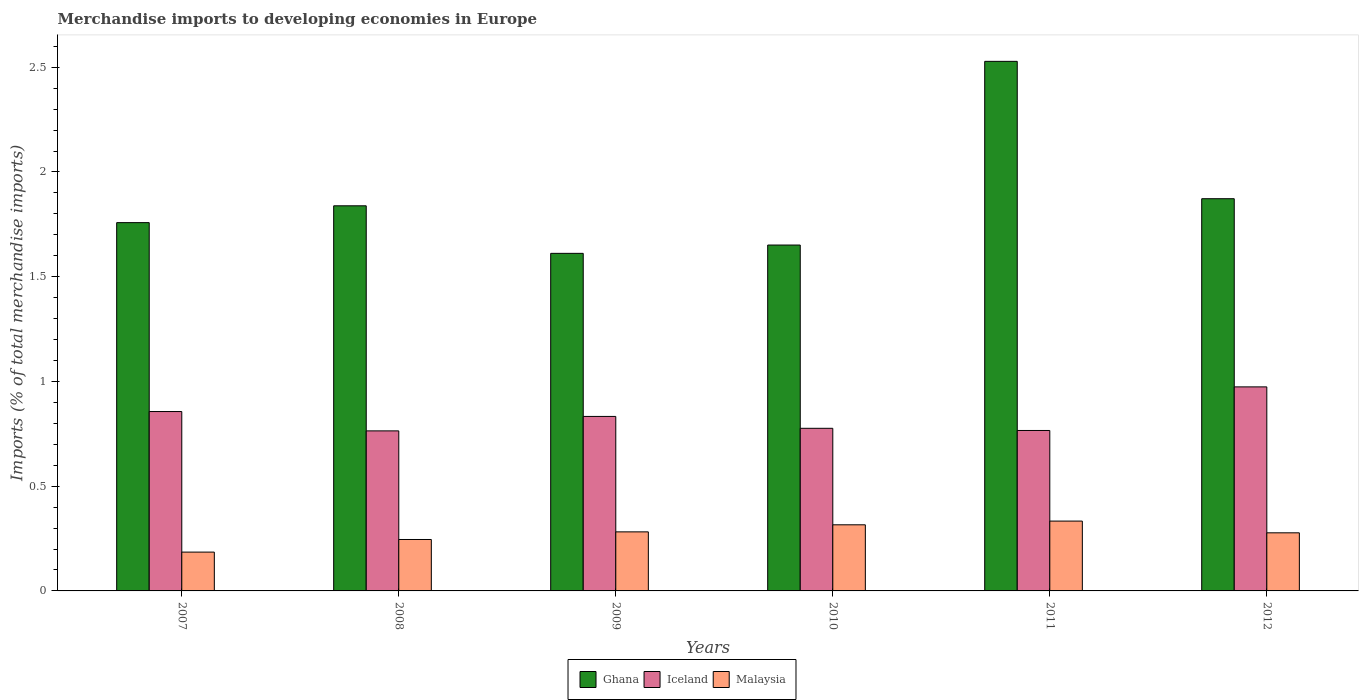How many groups of bars are there?
Offer a very short reply. 6. Are the number of bars per tick equal to the number of legend labels?
Ensure brevity in your answer.  Yes. Are the number of bars on each tick of the X-axis equal?
Keep it short and to the point. Yes. How many bars are there on the 6th tick from the left?
Keep it short and to the point. 3. How many bars are there on the 2nd tick from the right?
Offer a very short reply. 3. What is the label of the 1st group of bars from the left?
Offer a terse response. 2007. In how many cases, is the number of bars for a given year not equal to the number of legend labels?
Provide a succinct answer. 0. What is the percentage total merchandise imports in Malaysia in 2007?
Keep it short and to the point. 0.19. Across all years, what is the maximum percentage total merchandise imports in Ghana?
Your response must be concise. 2.53. Across all years, what is the minimum percentage total merchandise imports in Ghana?
Make the answer very short. 1.61. In which year was the percentage total merchandise imports in Malaysia maximum?
Your answer should be very brief. 2011. What is the total percentage total merchandise imports in Ghana in the graph?
Your response must be concise. 11.26. What is the difference between the percentage total merchandise imports in Iceland in 2008 and that in 2009?
Offer a terse response. -0.07. What is the difference between the percentage total merchandise imports in Iceland in 2011 and the percentage total merchandise imports in Malaysia in 2007?
Make the answer very short. 0.58. What is the average percentage total merchandise imports in Ghana per year?
Offer a very short reply. 1.88. In the year 2010, what is the difference between the percentage total merchandise imports in Malaysia and percentage total merchandise imports in Ghana?
Provide a succinct answer. -1.34. In how many years, is the percentage total merchandise imports in Malaysia greater than 1.6 %?
Make the answer very short. 0. What is the ratio of the percentage total merchandise imports in Ghana in 2007 to that in 2009?
Give a very brief answer. 1.09. What is the difference between the highest and the second highest percentage total merchandise imports in Iceland?
Give a very brief answer. 0.12. What is the difference between the highest and the lowest percentage total merchandise imports in Malaysia?
Provide a short and direct response. 0.15. What does the 1st bar from the left in 2012 represents?
Offer a terse response. Ghana. What does the 3rd bar from the right in 2012 represents?
Provide a succinct answer. Ghana. How many bars are there?
Offer a terse response. 18. Are the values on the major ticks of Y-axis written in scientific E-notation?
Provide a short and direct response. No. Does the graph contain grids?
Keep it short and to the point. No. Where does the legend appear in the graph?
Ensure brevity in your answer.  Bottom center. How are the legend labels stacked?
Make the answer very short. Horizontal. What is the title of the graph?
Offer a very short reply. Merchandise imports to developing economies in Europe. Does "Nicaragua" appear as one of the legend labels in the graph?
Ensure brevity in your answer.  No. What is the label or title of the Y-axis?
Provide a succinct answer. Imports (% of total merchandise imports). What is the Imports (% of total merchandise imports) in Ghana in 2007?
Keep it short and to the point. 1.76. What is the Imports (% of total merchandise imports) in Iceland in 2007?
Provide a succinct answer. 0.86. What is the Imports (% of total merchandise imports) in Malaysia in 2007?
Your answer should be compact. 0.19. What is the Imports (% of total merchandise imports) in Ghana in 2008?
Keep it short and to the point. 1.84. What is the Imports (% of total merchandise imports) of Iceland in 2008?
Provide a short and direct response. 0.76. What is the Imports (% of total merchandise imports) in Malaysia in 2008?
Your response must be concise. 0.25. What is the Imports (% of total merchandise imports) of Ghana in 2009?
Keep it short and to the point. 1.61. What is the Imports (% of total merchandise imports) in Iceland in 2009?
Your answer should be compact. 0.83. What is the Imports (% of total merchandise imports) in Malaysia in 2009?
Ensure brevity in your answer.  0.28. What is the Imports (% of total merchandise imports) of Ghana in 2010?
Provide a succinct answer. 1.65. What is the Imports (% of total merchandise imports) of Iceland in 2010?
Provide a succinct answer. 0.78. What is the Imports (% of total merchandise imports) of Malaysia in 2010?
Make the answer very short. 0.32. What is the Imports (% of total merchandise imports) of Ghana in 2011?
Keep it short and to the point. 2.53. What is the Imports (% of total merchandise imports) of Iceland in 2011?
Offer a very short reply. 0.77. What is the Imports (% of total merchandise imports) in Malaysia in 2011?
Your response must be concise. 0.33. What is the Imports (% of total merchandise imports) in Ghana in 2012?
Offer a very short reply. 1.87. What is the Imports (% of total merchandise imports) in Iceland in 2012?
Offer a terse response. 0.97. What is the Imports (% of total merchandise imports) of Malaysia in 2012?
Provide a short and direct response. 0.28. Across all years, what is the maximum Imports (% of total merchandise imports) of Ghana?
Offer a very short reply. 2.53. Across all years, what is the maximum Imports (% of total merchandise imports) in Iceland?
Make the answer very short. 0.97. Across all years, what is the maximum Imports (% of total merchandise imports) of Malaysia?
Make the answer very short. 0.33. Across all years, what is the minimum Imports (% of total merchandise imports) of Ghana?
Give a very brief answer. 1.61. Across all years, what is the minimum Imports (% of total merchandise imports) of Iceland?
Offer a terse response. 0.76. Across all years, what is the minimum Imports (% of total merchandise imports) in Malaysia?
Make the answer very short. 0.19. What is the total Imports (% of total merchandise imports) in Ghana in the graph?
Ensure brevity in your answer.  11.26. What is the total Imports (% of total merchandise imports) of Iceland in the graph?
Your response must be concise. 4.97. What is the total Imports (% of total merchandise imports) in Malaysia in the graph?
Offer a very short reply. 1.64. What is the difference between the Imports (% of total merchandise imports) in Ghana in 2007 and that in 2008?
Provide a short and direct response. -0.08. What is the difference between the Imports (% of total merchandise imports) of Iceland in 2007 and that in 2008?
Offer a terse response. 0.09. What is the difference between the Imports (% of total merchandise imports) in Malaysia in 2007 and that in 2008?
Keep it short and to the point. -0.06. What is the difference between the Imports (% of total merchandise imports) of Ghana in 2007 and that in 2009?
Make the answer very short. 0.15. What is the difference between the Imports (% of total merchandise imports) of Iceland in 2007 and that in 2009?
Your answer should be very brief. 0.02. What is the difference between the Imports (% of total merchandise imports) of Malaysia in 2007 and that in 2009?
Your answer should be compact. -0.1. What is the difference between the Imports (% of total merchandise imports) in Ghana in 2007 and that in 2010?
Provide a short and direct response. 0.11. What is the difference between the Imports (% of total merchandise imports) of Iceland in 2007 and that in 2010?
Offer a very short reply. 0.08. What is the difference between the Imports (% of total merchandise imports) in Malaysia in 2007 and that in 2010?
Offer a terse response. -0.13. What is the difference between the Imports (% of total merchandise imports) in Ghana in 2007 and that in 2011?
Provide a succinct answer. -0.77. What is the difference between the Imports (% of total merchandise imports) of Iceland in 2007 and that in 2011?
Offer a very short reply. 0.09. What is the difference between the Imports (% of total merchandise imports) in Malaysia in 2007 and that in 2011?
Offer a terse response. -0.15. What is the difference between the Imports (% of total merchandise imports) of Ghana in 2007 and that in 2012?
Give a very brief answer. -0.11. What is the difference between the Imports (% of total merchandise imports) in Iceland in 2007 and that in 2012?
Offer a terse response. -0.12. What is the difference between the Imports (% of total merchandise imports) in Malaysia in 2007 and that in 2012?
Keep it short and to the point. -0.09. What is the difference between the Imports (% of total merchandise imports) of Ghana in 2008 and that in 2009?
Make the answer very short. 0.23. What is the difference between the Imports (% of total merchandise imports) in Iceland in 2008 and that in 2009?
Give a very brief answer. -0.07. What is the difference between the Imports (% of total merchandise imports) in Malaysia in 2008 and that in 2009?
Offer a terse response. -0.04. What is the difference between the Imports (% of total merchandise imports) in Ghana in 2008 and that in 2010?
Ensure brevity in your answer.  0.19. What is the difference between the Imports (% of total merchandise imports) of Iceland in 2008 and that in 2010?
Your answer should be very brief. -0.01. What is the difference between the Imports (% of total merchandise imports) in Malaysia in 2008 and that in 2010?
Offer a very short reply. -0.07. What is the difference between the Imports (% of total merchandise imports) of Ghana in 2008 and that in 2011?
Keep it short and to the point. -0.69. What is the difference between the Imports (% of total merchandise imports) in Iceland in 2008 and that in 2011?
Offer a very short reply. -0. What is the difference between the Imports (% of total merchandise imports) in Malaysia in 2008 and that in 2011?
Offer a terse response. -0.09. What is the difference between the Imports (% of total merchandise imports) in Ghana in 2008 and that in 2012?
Give a very brief answer. -0.03. What is the difference between the Imports (% of total merchandise imports) in Iceland in 2008 and that in 2012?
Ensure brevity in your answer.  -0.21. What is the difference between the Imports (% of total merchandise imports) of Malaysia in 2008 and that in 2012?
Keep it short and to the point. -0.03. What is the difference between the Imports (% of total merchandise imports) of Ghana in 2009 and that in 2010?
Offer a very short reply. -0.04. What is the difference between the Imports (% of total merchandise imports) in Iceland in 2009 and that in 2010?
Provide a succinct answer. 0.06. What is the difference between the Imports (% of total merchandise imports) of Malaysia in 2009 and that in 2010?
Make the answer very short. -0.03. What is the difference between the Imports (% of total merchandise imports) in Ghana in 2009 and that in 2011?
Provide a succinct answer. -0.92. What is the difference between the Imports (% of total merchandise imports) in Iceland in 2009 and that in 2011?
Provide a short and direct response. 0.07. What is the difference between the Imports (% of total merchandise imports) of Malaysia in 2009 and that in 2011?
Give a very brief answer. -0.05. What is the difference between the Imports (% of total merchandise imports) of Ghana in 2009 and that in 2012?
Keep it short and to the point. -0.26. What is the difference between the Imports (% of total merchandise imports) in Iceland in 2009 and that in 2012?
Provide a succinct answer. -0.14. What is the difference between the Imports (% of total merchandise imports) of Malaysia in 2009 and that in 2012?
Ensure brevity in your answer.  0. What is the difference between the Imports (% of total merchandise imports) in Ghana in 2010 and that in 2011?
Your answer should be compact. -0.88. What is the difference between the Imports (% of total merchandise imports) of Iceland in 2010 and that in 2011?
Give a very brief answer. 0.01. What is the difference between the Imports (% of total merchandise imports) in Malaysia in 2010 and that in 2011?
Offer a very short reply. -0.02. What is the difference between the Imports (% of total merchandise imports) of Ghana in 2010 and that in 2012?
Give a very brief answer. -0.22. What is the difference between the Imports (% of total merchandise imports) in Iceland in 2010 and that in 2012?
Your response must be concise. -0.2. What is the difference between the Imports (% of total merchandise imports) of Malaysia in 2010 and that in 2012?
Keep it short and to the point. 0.04. What is the difference between the Imports (% of total merchandise imports) in Ghana in 2011 and that in 2012?
Provide a succinct answer. 0.66. What is the difference between the Imports (% of total merchandise imports) in Iceland in 2011 and that in 2012?
Your answer should be compact. -0.21. What is the difference between the Imports (% of total merchandise imports) of Malaysia in 2011 and that in 2012?
Provide a succinct answer. 0.06. What is the difference between the Imports (% of total merchandise imports) of Ghana in 2007 and the Imports (% of total merchandise imports) of Iceland in 2008?
Your response must be concise. 0.99. What is the difference between the Imports (% of total merchandise imports) in Ghana in 2007 and the Imports (% of total merchandise imports) in Malaysia in 2008?
Give a very brief answer. 1.51. What is the difference between the Imports (% of total merchandise imports) in Iceland in 2007 and the Imports (% of total merchandise imports) in Malaysia in 2008?
Keep it short and to the point. 0.61. What is the difference between the Imports (% of total merchandise imports) in Ghana in 2007 and the Imports (% of total merchandise imports) in Iceland in 2009?
Your answer should be very brief. 0.93. What is the difference between the Imports (% of total merchandise imports) in Ghana in 2007 and the Imports (% of total merchandise imports) in Malaysia in 2009?
Give a very brief answer. 1.48. What is the difference between the Imports (% of total merchandise imports) of Iceland in 2007 and the Imports (% of total merchandise imports) of Malaysia in 2009?
Offer a terse response. 0.57. What is the difference between the Imports (% of total merchandise imports) in Ghana in 2007 and the Imports (% of total merchandise imports) in Iceland in 2010?
Offer a very short reply. 0.98. What is the difference between the Imports (% of total merchandise imports) in Ghana in 2007 and the Imports (% of total merchandise imports) in Malaysia in 2010?
Give a very brief answer. 1.44. What is the difference between the Imports (% of total merchandise imports) of Iceland in 2007 and the Imports (% of total merchandise imports) of Malaysia in 2010?
Your answer should be very brief. 0.54. What is the difference between the Imports (% of total merchandise imports) in Ghana in 2007 and the Imports (% of total merchandise imports) in Malaysia in 2011?
Your answer should be compact. 1.42. What is the difference between the Imports (% of total merchandise imports) of Iceland in 2007 and the Imports (% of total merchandise imports) of Malaysia in 2011?
Your answer should be very brief. 0.52. What is the difference between the Imports (% of total merchandise imports) of Ghana in 2007 and the Imports (% of total merchandise imports) of Iceland in 2012?
Provide a succinct answer. 0.78. What is the difference between the Imports (% of total merchandise imports) of Ghana in 2007 and the Imports (% of total merchandise imports) of Malaysia in 2012?
Give a very brief answer. 1.48. What is the difference between the Imports (% of total merchandise imports) of Iceland in 2007 and the Imports (% of total merchandise imports) of Malaysia in 2012?
Provide a short and direct response. 0.58. What is the difference between the Imports (% of total merchandise imports) in Ghana in 2008 and the Imports (% of total merchandise imports) in Malaysia in 2009?
Your answer should be compact. 1.56. What is the difference between the Imports (% of total merchandise imports) of Iceland in 2008 and the Imports (% of total merchandise imports) of Malaysia in 2009?
Give a very brief answer. 0.48. What is the difference between the Imports (% of total merchandise imports) in Ghana in 2008 and the Imports (% of total merchandise imports) in Iceland in 2010?
Keep it short and to the point. 1.06. What is the difference between the Imports (% of total merchandise imports) of Ghana in 2008 and the Imports (% of total merchandise imports) of Malaysia in 2010?
Provide a succinct answer. 1.52. What is the difference between the Imports (% of total merchandise imports) of Iceland in 2008 and the Imports (% of total merchandise imports) of Malaysia in 2010?
Provide a succinct answer. 0.45. What is the difference between the Imports (% of total merchandise imports) of Ghana in 2008 and the Imports (% of total merchandise imports) of Iceland in 2011?
Make the answer very short. 1.07. What is the difference between the Imports (% of total merchandise imports) of Ghana in 2008 and the Imports (% of total merchandise imports) of Malaysia in 2011?
Offer a terse response. 1.5. What is the difference between the Imports (% of total merchandise imports) of Iceland in 2008 and the Imports (% of total merchandise imports) of Malaysia in 2011?
Ensure brevity in your answer.  0.43. What is the difference between the Imports (% of total merchandise imports) in Ghana in 2008 and the Imports (% of total merchandise imports) in Iceland in 2012?
Offer a terse response. 0.86. What is the difference between the Imports (% of total merchandise imports) of Ghana in 2008 and the Imports (% of total merchandise imports) of Malaysia in 2012?
Keep it short and to the point. 1.56. What is the difference between the Imports (% of total merchandise imports) of Iceland in 2008 and the Imports (% of total merchandise imports) of Malaysia in 2012?
Offer a terse response. 0.49. What is the difference between the Imports (% of total merchandise imports) of Ghana in 2009 and the Imports (% of total merchandise imports) of Iceland in 2010?
Ensure brevity in your answer.  0.84. What is the difference between the Imports (% of total merchandise imports) in Ghana in 2009 and the Imports (% of total merchandise imports) in Malaysia in 2010?
Offer a very short reply. 1.3. What is the difference between the Imports (% of total merchandise imports) in Iceland in 2009 and the Imports (% of total merchandise imports) in Malaysia in 2010?
Keep it short and to the point. 0.52. What is the difference between the Imports (% of total merchandise imports) of Ghana in 2009 and the Imports (% of total merchandise imports) of Iceland in 2011?
Make the answer very short. 0.85. What is the difference between the Imports (% of total merchandise imports) of Ghana in 2009 and the Imports (% of total merchandise imports) of Malaysia in 2011?
Your answer should be compact. 1.28. What is the difference between the Imports (% of total merchandise imports) of Iceland in 2009 and the Imports (% of total merchandise imports) of Malaysia in 2011?
Ensure brevity in your answer.  0.5. What is the difference between the Imports (% of total merchandise imports) of Ghana in 2009 and the Imports (% of total merchandise imports) of Iceland in 2012?
Your answer should be very brief. 0.64. What is the difference between the Imports (% of total merchandise imports) of Ghana in 2009 and the Imports (% of total merchandise imports) of Malaysia in 2012?
Make the answer very short. 1.33. What is the difference between the Imports (% of total merchandise imports) of Iceland in 2009 and the Imports (% of total merchandise imports) of Malaysia in 2012?
Provide a short and direct response. 0.56. What is the difference between the Imports (% of total merchandise imports) in Ghana in 2010 and the Imports (% of total merchandise imports) in Iceland in 2011?
Ensure brevity in your answer.  0.89. What is the difference between the Imports (% of total merchandise imports) of Ghana in 2010 and the Imports (% of total merchandise imports) of Malaysia in 2011?
Ensure brevity in your answer.  1.32. What is the difference between the Imports (% of total merchandise imports) of Iceland in 2010 and the Imports (% of total merchandise imports) of Malaysia in 2011?
Ensure brevity in your answer.  0.44. What is the difference between the Imports (% of total merchandise imports) of Ghana in 2010 and the Imports (% of total merchandise imports) of Iceland in 2012?
Provide a short and direct response. 0.68. What is the difference between the Imports (% of total merchandise imports) of Ghana in 2010 and the Imports (% of total merchandise imports) of Malaysia in 2012?
Provide a succinct answer. 1.37. What is the difference between the Imports (% of total merchandise imports) in Iceland in 2010 and the Imports (% of total merchandise imports) in Malaysia in 2012?
Your response must be concise. 0.5. What is the difference between the Imports (% of total merchandise imports) in Ghana in 2011 and the Imports (% of total merchandise imports) in Iceland in 2012?
Offer a terse response. 1.55. What is the difference between the Imports (% of total merchandise imports) of Ghana in 2011 and the Imports (% of total merchandise imports) of Malaysia in 2012?
Offer a terse response. 2.25. What is the difference between the Imports (% of total merchandise imports) of Iceland in 2011 and the Imports (% of total merchandise imports) of Malaysia in 2012?
Make the answer very short. 0.49. What is the average Imports (% of total merchandise imports) of Ghana per year?
Keep it short and to the point. 1.88. What is the average Imports (% of total merchandise imports) in Iceland per year?
Your answer should be compact. 0.83. What is the average Imports (% of total merchandise imports) of Malaysia per year?
Your answer should be compact. 0.27. In the year 2007, what is the difference between the Imports (% of total merchandise imports) in Ghana and Imports (% of total merchandise imports) in Iceland?
Provide a succinct answer. 0.9. In the year 2007, what is the difference between the Imports (% of total merchandise imports) of Ghana and Imports (% of total merchandise imports) of Malaysia?
Ensure brevity in your answer.  1.57. In the year 2007, what is the difference between the Imports (% of total merchandise imports) of Iceland and Imports (% of total merchandise imports) of Malaysia?
Your answer should be very brief. 0.67. In the year 2008, what is the difference between the Imports (% of total merchandise imports) in Ghana and Imports (% of total merchandise imports) in Iceland?
Make the answer very short. 1.07. In the year 2008, what is the difference between the Imports (% of total merchandise imports) in Ghana and Imports (% of total merchandise imports) in Malaysia?
Make the answer very short. 1.59. In the year 2008, what is the difference between the Imports (% of total merchandise imports) in Iceland and Imports (% of total merchandise imports) in Malaysia?
Keep it short and to the point. 0.52. In the year 2009, what is the difference between the Imports (% of total merchandise imports) in Ghana and Imports (% of total merchandise imports) in Iceland?
Your answer should be compact. 0.78. In the year 2009, what is the difference between the Imports (% of total merchandise imports) of Ghana and Imports (% of total merchandise imports) of Malaysia?
Your answer should be compact. 1.33. In the year 2009, what is the difference between the Imports (% of total merchandise imports) in Iceland and Imports (% of total merchandise imports) in Malaysia?
Keep it short and to the point. 0.55. In the year 2010, what is the difference between the Imports (% of total merchandise imports) of Ghana and Imports (% of total merchandise imports) of Iceland?
Give a very brief answer. 0.87. In the year 2010, what is the difference between the Imports (% of total merchandise imports) in Ghana and Imports (% of total merchandise imports) in Malaysia?
Offer a terse response. 1.34. In the year 2010, what is the difference between the Imports (% of total merchandise imports) of Iceland and Imports (% of total merchandise imports) of Malaysia?
Give a very brief answer. 0.46. In the year 2011, what is the difference between the Imports (% of total merchandise imports) of Ghana and Imports (% of total merchandise imports) of Iceland?
Your response must be concise. 1.76. In the year 2011, what is the difference between the Imports (% of total merchandise imports) of Ghana and Imports (% of total merchandise imports) of Malaysia?
Give a very brief answer. 2.19. In the year 2011, what is the difference between the Imports (% of total merchandise imports) in Iceland and Imports (% of total merchandise imports) in Malaysia?
Make the answer very short. 0.43. In the year 2012, what is the difference between the Imports (% of total merchandise imports) of Ghana and Imports (% of total merchandise imports) of Iceland?
Ensure brevity in your answer.  0.9. In the year 2012, what is the difference between the Imports (% of total merchandise imports) of Ghana and Imports (% of total merchandise imports) of Malaysia?
Offer a terse response. 1.59. In the year 2012, what is the difference between the Imports (% of total merchandise imports) in Iceland and Imports (% of total merchandise imports) in Malaysia?
Offer a very short reply. 0.7. What is the ratio of the Imports (% of total merchandise imports) in Ghana in 2007 to that in 2008?
Make the answer very short. 0.96. What is the ratio of the Imports (% of total merchandise imports) of Iceland in 2007 to that in 2008?
Your answer should be compact. 1.12. What is the ratio of the Imports (% of total merchandise imports) of Malaysia in 2007 to that in 2008?
Provide a succinct answer. 0.75. What is the ratio of the Imports (% of total merchandise imports) of Ghana in 2007 to that in 2009?
Keep it short and to the point. 1.09. What is the ratio of the Imports (% of total merchandise imports) in Iceland in 2007 to that in 2009?
Make the answer very short. 1.03. What is the ratio of the Imports (% of total merchandise imports) of Malaysia in 2007 to that in 2009?
Your answer should be very brief. 0.66. What is the ratio of the Imports (% of total merchandise imports) of Ghana in 2007 to that in 2010?
Your answer should be compact. 1.06. What is the ratio of the Imports (% of total merchandise imports) in Iceland in 2007 to that in 2010?
Make the answer very short. 1.1. What is the ratio of the Imports (% of total merchandise imports) in Malaysia in 2007 to that in 2010?
Your answer should be compact. 0.59. What is the ratio of the Imports (% of total merchandise imports) in Ghana in 2007 to that in 2011?
Your response must be concise. 0.7. What is the ratio of the Imports (% of total merchandise imports) of Iceland in 2007 to that in 2011?
Give a very brief answer. 1.12. What is the ratio of the Imports (% of total merchandise imports) in Malaysia in 2007 to that in 2011?
Provide a short and direct response. 0.56. What is the ratio of the Imports (% of total merchandise imports) in Ghana in 2007 to that in 2012?
Provide a succinct answer. 0.94. What is the ratio of the Imports (% of total merchandise imports) in Iceland in 2007 to that in 2012?
Your answer should be compact. 0.88. What is the ratio of the Imports (% of total merchandise imports) in Malaysia in 2007 to that in 2012?
Make the answer very short. 0.67. What is the ratio of the Imports (% of total merchandise imports) in Ghana in 2008 to that in 2009?
Offer a very short reply. 1.14. What is the ratio of the Imports (% of total merchandise imports) of Iceland in 2008 to that in 2009?
Offer a terse response. 0.92. What is the ratio of the Imports (% of total merchandise imports) in Malaysia in 2008 to that in 2009?
Your answer should be very brief. 0.87. What is the ratio of the Imports (% of total merchandise imports) of Ghana in 2008 to that in 2010?
Give a very brief answer. 1.11. What is the ratio of the Imports (% of total merchandise imports) of Iceland in 2008 to that in 2010?
Your response must be concise. 0.98. What is the ratio of the Imports (% of total merchandise imports) in Malaysia in 2008 to that in 2010?
Provide a short and direct response. 0.78. What is the ratio of the Imports (% of total merchandise imports) of Ghana in 2008 to that in 2011?
Ensure brevity in your answer.  0.73. What is the ratio of the Imports (% of total merchandise imports) in Iceland in 2008 to that in 2011?
Your answer should be very brief. 1. What is the ratio of the Imports (% of total merchandise imports) of Malaysia in 2008 to that in 2011?
Provide a succinct answer. 0.74. What is the ratio of the Imports (% of total merchandise imports) in Ghana in 2008 to that in 2012?
Offer a terse response. 0.98. What is the ratio of the Imports (% of total merchandise imports) of Iceland in 2008 to that in 2012?
Offer a terse response. 0.78. What is the ratio of the Imports (% of total merchandise imports) in Malaysia in 2008 to that in 2012?
Give a very brief answer. 0.89. What is the ratio of the Imports (% of total merchandise imports) in Iceland in 2009 to that in 2010?
Your response must be concise. 1.07. What is the ratio of the Imports (% of total merchandise imports) of Malaysia in 2009 to that in 2010?
Provide a succinct answer. 0.89. What is the ratio of the Imports (% of total merchandise imports) of Ghana in 2009 to that in 2011?
Make the answer very short. 0.64. What is the ratio of the Imports (% of total merchandise imports) of Iceland in 2009 to that in 2011?
Provide a short and direct response. 1.09. What is the ratio of the Imports (% of total merchandise imports) in Malaysia in 2009 to that in 2011?
Ensure brevity in your answer.  0.85. What is the ratio of the Imports (% of total merchandise imports) of Ghana in 2009 to that in 2012?
Ensure brevity in your answer.  0.86. What is the ratio of the Imports (% of total merchandise imports) in Iceland in 2009 to that in 2012?
Provide a short and direct response. 0.86. What is the ratio of the Imports (% of total merchandise imports) of Malaysia in 2009 to that in 2012?
Provide a succinct answer. 1.02. What is the ratio of the Imports (% of total merchandise imports) in Ghana in 2010 to that in 2011?
Provide a short and direct response. 0.65. What is the ratio of the Imports (% of total merchandise imports) of Iceland in 2010 to that in 2011?
Provide a succinct answer. 1.01. What is the ratio of the Imports (% of total merchandise imports) of Malaysia in 2010 to that in 2011?
Your response must be concise. 0.95. What is the ratio of the Imports (% of total merchandise imports) of Ghana in 2010 to that in 2012?
Provide a succinct answer. 0.88. What is the ratio of the Imports (% of total merchandise imports) in Iceland in 2010 to that in 2012?
Keep it short and to the point. 0.8. What is the ratio of the Imports (% of total merchandise imports) in Malaysia in 2010 to that in 2012?
Give a very brief answer. 1.14. What is the ratio of the Imports (% of total merchandise imports) of Ghana in 2011 to that in 2012?
Your answer should be compact. 1.35. What is the ratio of the Imports (% of total merchandise imports) of Iceland in 2011 to that in 2012?
Give a very brief answer. 0.79. What is the ratio of the Imports (% of total merchandise imports) of Malaysia in 2011 to that in 2012?
Provide a succinct answer. 1.2. What is the difference between the highest and the second highest Imports (% of total merchandise imports) of Ghana?
Offer a very short reply. 0.66. What is the difference between the highest and the second highest Imports (% of total merchandise imports) of Iceland?
Ensure brevity in your answer.  0.12. What is the difference between the highest and the second highest Imports (% of total merchandise imports) in Malaysia?
Your response must be concise. 0.02. What is the difference between the highest and the lowest Imports (% of total merchandise imports) in Ghana?
Your answer should be very brief. 0.92. What is the difference between the highest and the lowest Imports (% of total merchandise imports) of Iceland?
Your answer should be compact. 0.21. What is the difference between the highest and the lowest Imports (% of total merchandise imports) in Malaysia?
Your response must be concise. 0.15. 